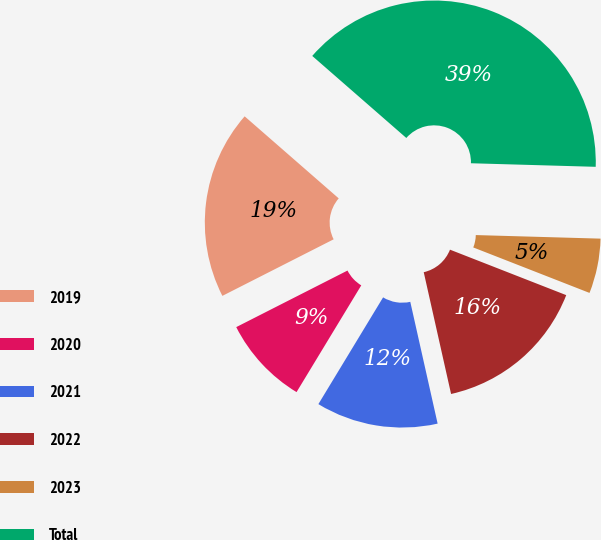<chart> <loc_0><loc_0><loc_500><loc_500><pie_chart><fcel>2019<fcel>2020<fcel>2021<fcel>2022<fcel>2023<fcel>Total<nl><fcel>18.9%<fcel>8.84%<fcel>12.19%<fcel>15.55%<fcel>5.48%<fcel>39.04%<nl></chart> 